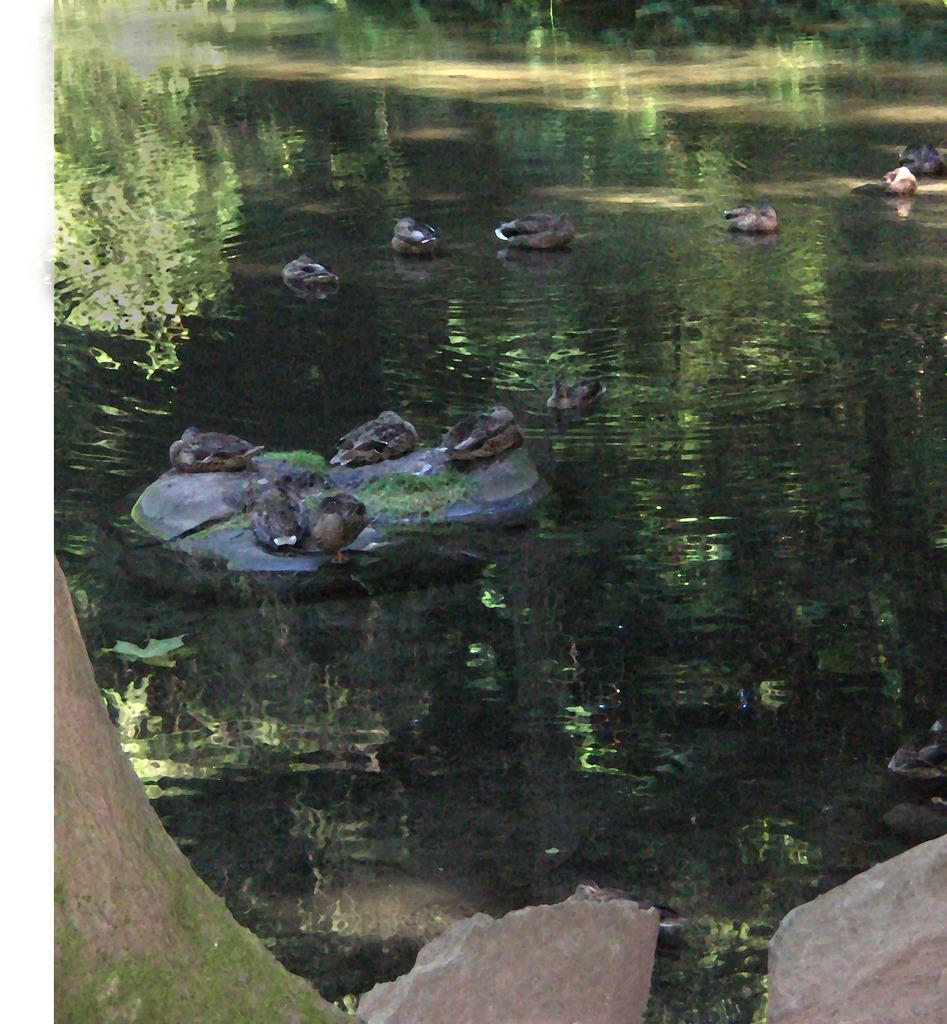What animals can be seen in the image? There are ducks swimming in the water and ducks sitting on a rock. What is the primary element in which the ducks are situated? The ducks are situated in water. Can you describe the setting where the ducks are located? The ducks are located in a body of water with a rock nearby. What type of unit can be seen in the image? There is no unit present in the image; it features ducks swimming in water and sitting on a rock. Can you describe the thrill experienced by the zebra in the image? There is no zebra present in the image, so it is not possible to describe any thrill experienced by a zebra. 